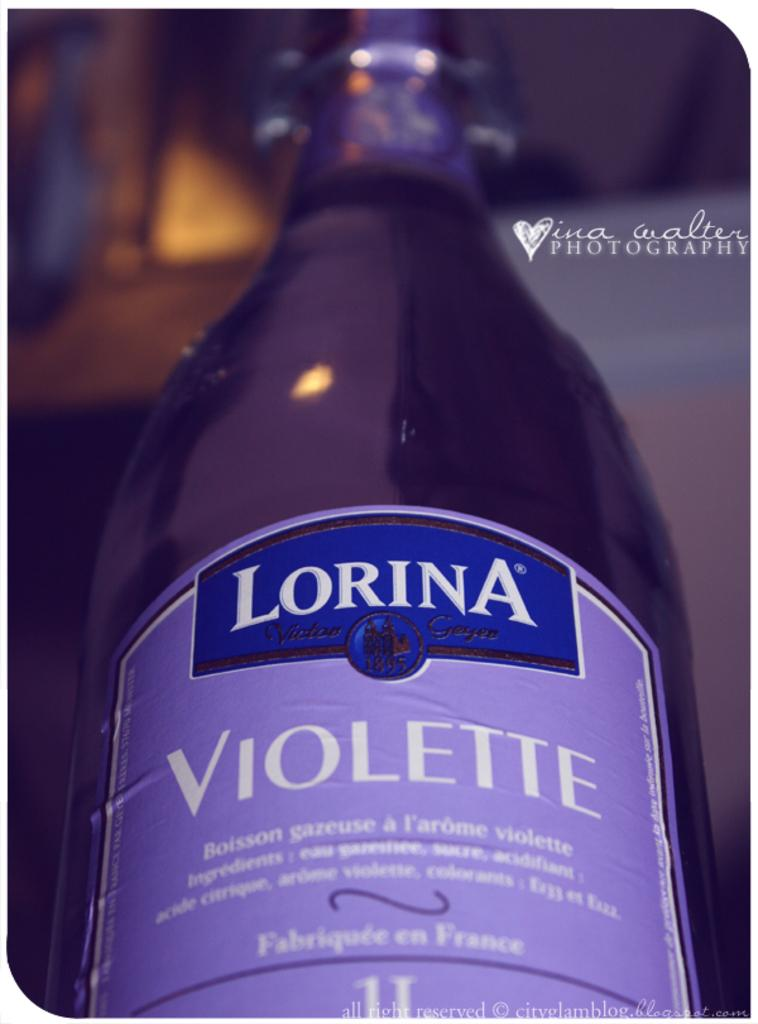What object can be seen in the image? There is a bottle in the image. What type of bottle is it? The bottle resembles a wine bottle. What color is the bottle? The bottle is violet in color. Is there any text or design on the bottle? Yes, there is a label attached to the bottle. What type of soda is being advertised on the label of the bottle? There is no soda mentioned or depicted in the image; the bottle resembles a wine bottle and has a violet color. 